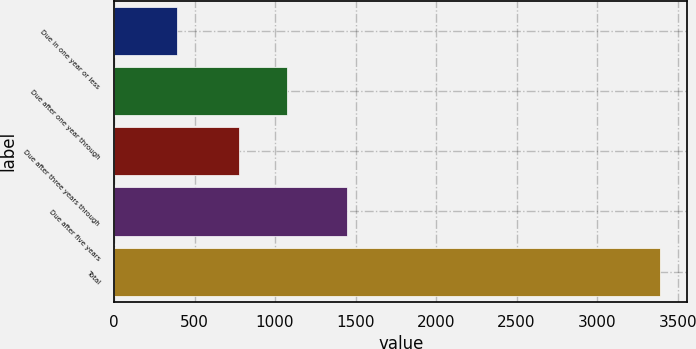<chart> <loc_0><loc_0><loc_500><loc_500><bar_chart><fcel>Due in one year or less<fcel>Due after one year through<fcel>Due after three years through<fcel>Due after five years<fcel>Total<nl><fcel>394.3<fcel>1074.01<fcel>774.3<fcel>1446.8<fcel>3391.4<nl></chart> 